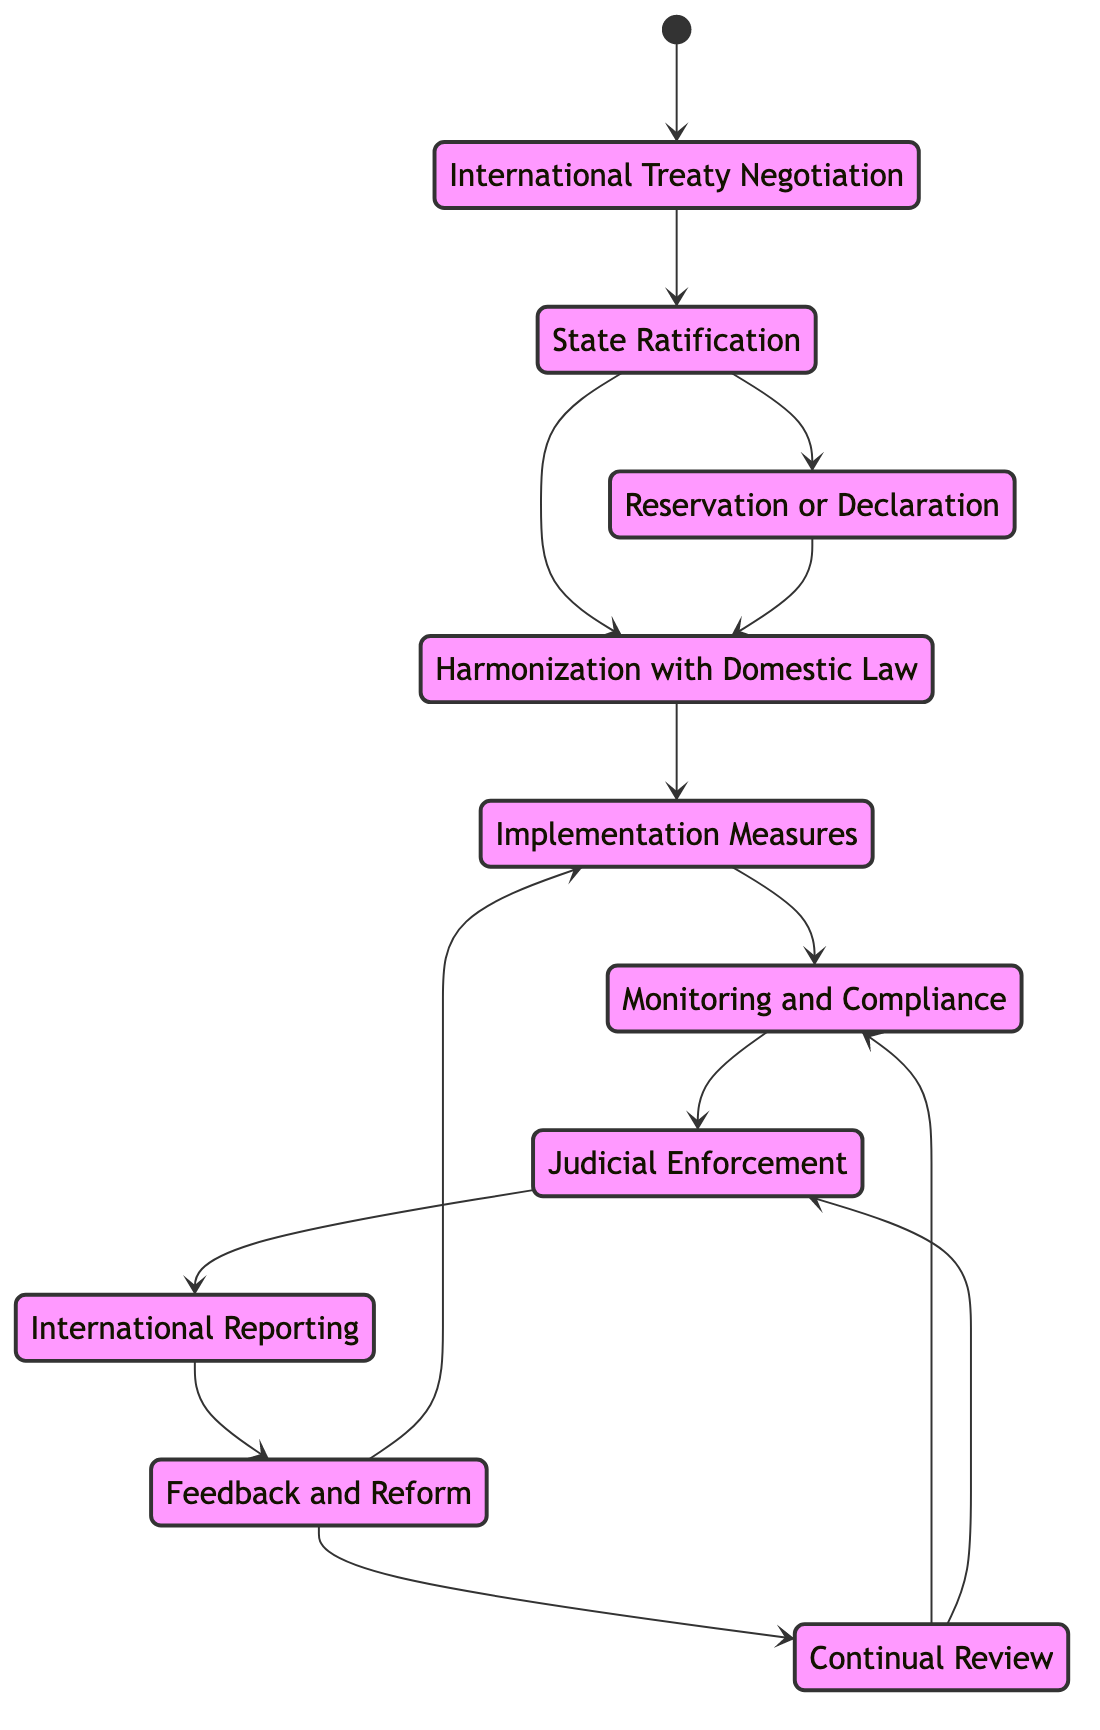What is the first step in the lifecycle of implementing international human rights legislation? The first step shown in the diagram is "International Treaty Negotiation," which indicates the initial phase where human rights norms are discussed and agreed upon in international forums.
Answer: International Treaty Negotiation How many transitions lead from "State Ratification"? The "State Ratification" node has two outgoing transitions, which indicate that there are two possible next steps: either to "Harmonization with Domestic Law" or to "Reservation or Declaration."
Answer: Two What process follows "Harmonization with Domestic Law"? The diagram indicates that "Implementation Measures" follows directly after "Harmonization with Domestic Law," showing the logical progression of the legislation lifecycle.
Answer: Implementation Measures What node can be reached after "Feedback and Reform"? "Feedback and Reform" has two possible next steps: it can lead back to either "Implementation Measures" or to "Continual Review," indicating ongoing adjustments in the legislative process.
Answer: Implementation Measures or Continual Review What is the final step mentioned in the lifecycle? There are two nodes that can be categorized as final stages in the context of ongoing processes: "Judicial Enforcement" and "Continual Review," both of which signify adherence to and renewal of human rights standards.
Answer: Judicial Enforcement or Continual Review If a state chooses to implement "Reservation or Declaration," what is the next step it can take? After making a "Reservation or Declaration," the state must continue with "Harmonization with Domestic Law," suggesting that such declarations require alignment with domestic laws for full adherence.
Answer: Harmonization with Domestic Law How does "Monitoring and Compliance" connect to the overall process? "Monitoring and Compliance" is crucial in ensuring that the implemented measures are followed; it comes after "Implementation Measures" and links directly to "Judicial Enforcement," showcasing a flow of accountability.
Answer: Judicial Enforcement What does the "International Reporting" step entail? The "International Reporting" node refers to the process where states submit nation-specific human rights reports to international organizations, reflecting a commitment to transparency and engagement.
Answer: International Reporting 